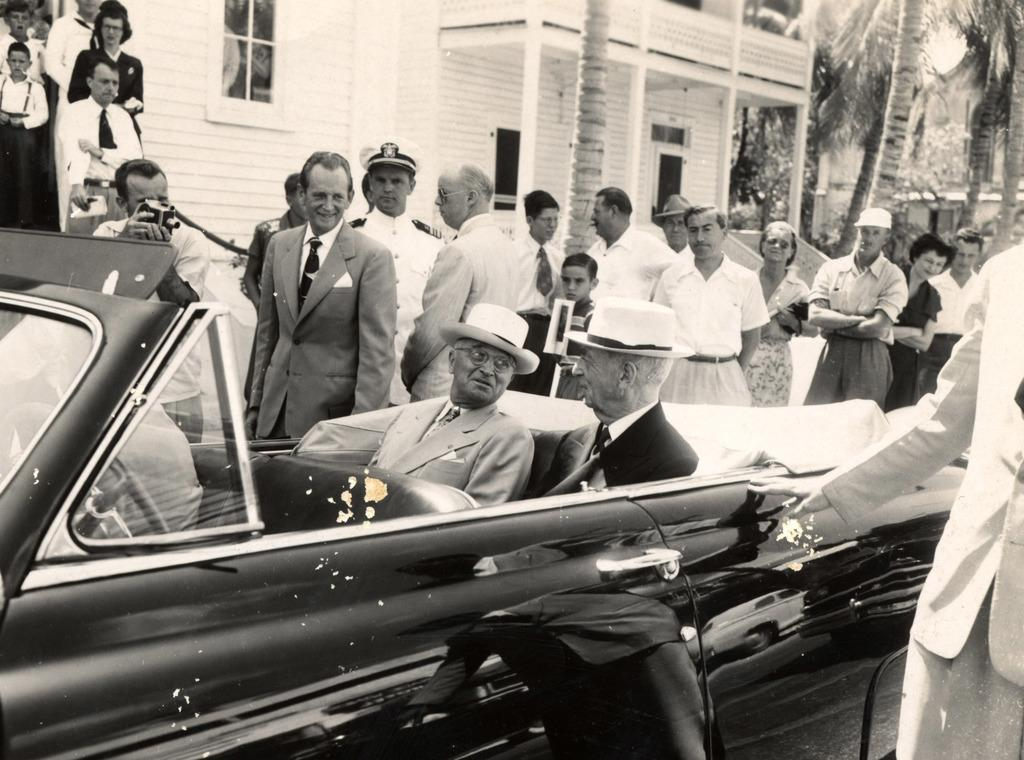What is happening in the image involving people? There are people standing in the image. Can you describe the vehicles in the image? There are two men in a car. Who is holding a camera in the image? There is a man holding a camera. What type of structure can be seen in the image? There is a building in the image. What can be seen in the background of the image? There are trees in the background of the image. What type of hat is the man wearing while performing the action in the image? There is no man performing an action in the image, nor is there a hat present. 